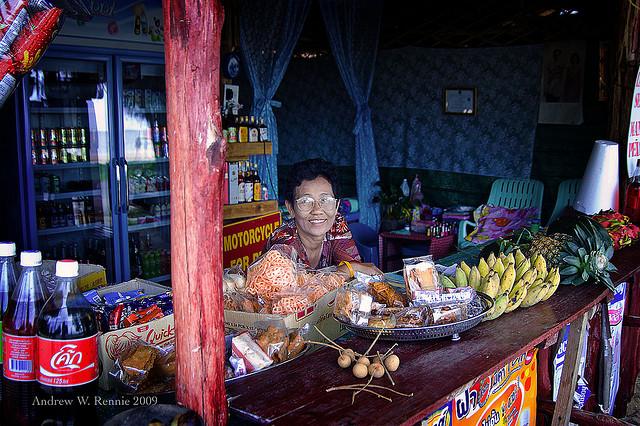What type of beverage is sitting on the front counter top?
Give a very brief answer. Coke. Is the woman sad?
Be succinct. No. Why is there a curtain hanging up?
Concise answer only. Privacy. 